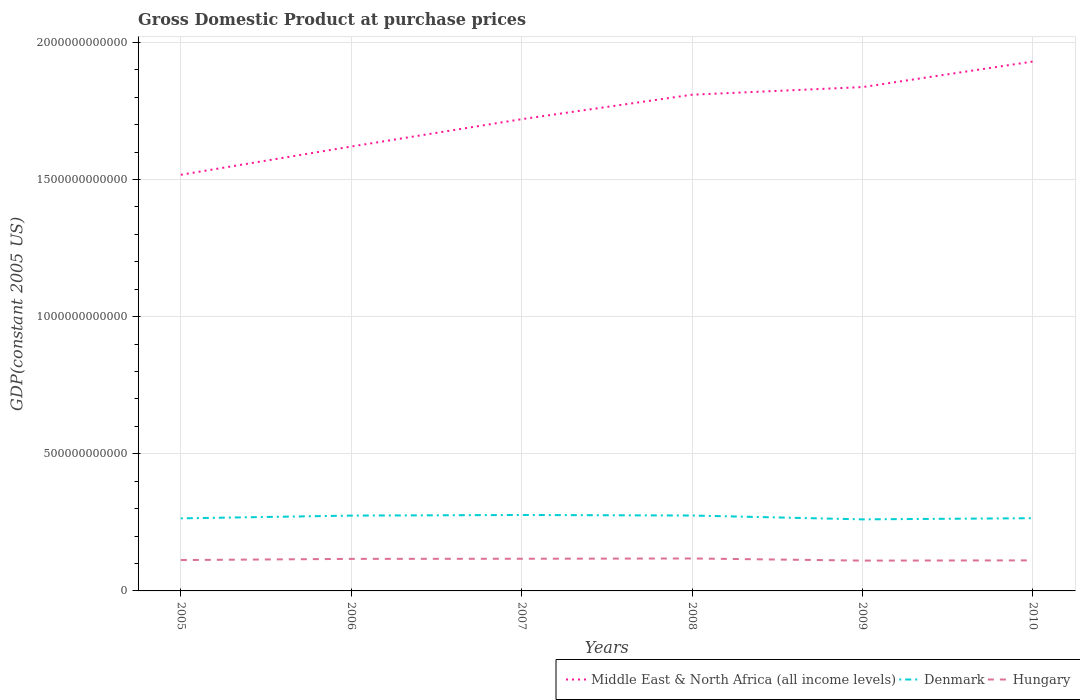How many different coloured lines are there?
Your response must be concise. 3. Across all years, what is the maximum GDP at purchase prices in Middle East & North Africa (all income levels)?
Keep it short and to the point. 1.52e+12. In which year was the GDP at purchase prices in Denmark maximum?
Give a very brief answer. 2009. What is the total GDP at purchase prices in Hungary in the graph?
Your answer should be compact. -4.78e+09. What is the difference between the highest and the second highest GDP at purchase prices in Middle East & North Africa (all income levels)?
Provide a short and direct response. 4.13e+11. Is the GDP at purchase prices in Denmark strictly greater than the GDP at purchase prices in Hungary over the years?
Offer a terse response. No. How many years are there in the graph?
Provide a succinct answer. 6. What is the difference between two consecutive major ticks on the Y-axis?
Your answer should be very brief. 5.00e+11. Are the values on the major ticks of Y-axis written in scientific E-notation?
Offer a terse response. No. How are the legend labels stacked?
Your answer should be compact. Horizontal. What is the title of the graph?
Offer a terse response. Gross Domestic Product at purchase prices. What is the label or title of the Y-axis?
Your answer should be compact. GDP(constant 2005 US). What is the GDP(constant 2005 US) of Middle East & North Africa (all income levels) in 2005?
Your response must be concise. 1.52e+12. What is the GDP(constant 2005 US) in Denmark in 2005?
Your response must be concise. 2.65e+11. What is the GDP(constant 2005 US) in Hungary in 2005?
Your answer should be compact. 1.13e+11. What is the GDP(constant 2005 US) in Middle East & North Africa (all income levels) in 2006?
Offer a terse response. 1.62e+12. What is the GDP(constant 2005 US) of Denmark in 2006?
Your answer should be compact. 2.75e+11. What is the GDP(constant 2005 US) of Hungary in 2006?
Your answer should be very brief. 1.17e+11. What is the GDP(constant 2005 US) in Middle East & North Africa (all income levels) in 2007?
Provide a short and direct response. 1.72e+12. What is the GDP(constant 2005 US) in Denmark in 2007?
Keep it short and to the point. 2.77e+11. What is the GDP(constant 2005 US) of Hungary in 2007?
Give a very brief answer. 1.17e+11. What is the GDP(constant 2005 US) of Middle East & North Africa (all income levels) in 2008?
Your answer should be very brief. 1.81e+12. What is the GDP(constant 2005 US) of Denmark in 2008?
Offer a terse response. 2.75e+11. What is the GDP(constant 2005 US) of Hungary in 2008?
Keep it short and to the point. 1.18e+11. What is the GDP(constant 2005 US) in Middle East & North Africa (all income levels) in 2009?
Give a very brief answer. 1.84e+12. What is the GDP(constant 2005 US) in Denmark in 2009?
Offer a very short reply. 2.61e+11. What is the GDP(constant 2005 US) of Hungary in 2009?
Make the answer very short. 1.11e+11. What is the GDP(constant 2005 US) of Middle East & North Africa (all income levels) in 2010?
Provide a short and direct response. 1.93e+12. What is the GDP(constant 2005 US) of Denmark in 2010?
Your answer should be very brief. 2.65e+11. What is the GDP(constant 2005 US) of Hungary in 2010?
Your answer should be compact. 1.11e+11. Across all years, what is the maximum GDP(constant 2005 US) in Middle East & North Africa (all income levels)?
Make the answer very short. 1.93e+12. Across all years, what is the maximum GDP(constant 2005 US) of Denmark?
Your response must be concise. 2.77e+11. Across all years, what is the maximum GDP(constant 2005 US) in Hungary?
Provide a succinct answer. 1.18e+11. Across all years, what is the minimum GDP(constant 2005 US) of Middle East & North Africa (all income levels)?
Provide a short and direct response. 1.52e+12. Across all years, what is the minimum GDP(constant 2005 US) in Denmark?
Provide a succinct answer. 2.61e+11. Across all years, what is the minimum GDP(constant 2005 US) in Hungary?
Your answer should be very brief. 1.11e+11. What is the total GDP(constant 2005 US) in Middle East & North Africa (all income levels) in the graph?
Make the answer very short. 1.04e+13. What is the total GDP(constant 2005 US) of Denmark in the graph?
Offer a very short reply. 1.62e+12. What is the total GDP(constant 2005 US) in Hungary in the graph?
Your response must be concise. 6.87e+11. What is the difference between the GDP(constant 2005 US) in Middle East & North Africa (all income levels) in 2005 and that in 2006?
Offer a terse response. -1.03e+11. What is the difference between the GDP(constant 2005 US) of Denmark in 2005 and that in 2006?
Make the answer very short. -1.00e+1. What is the difference between the GDP(constant 2005 US) of Hungary in 2005 and that in 2006?
Give a very brief answer. -4.28e+09. What is the difference between the GDP(constant 2005 US) of Middle East & North Africa (all income levels) in 2005 and that in 2007?
Offer a terse response. -2.03e+11. What is the difference between the GDP(constant 2005 US) of Denmark in 2005 and that in 2007?
Offer a very short reply. -1.23e+1. What is the difference between the GDP(constant 2005 US) in Hungary in 2005 and that in 2007?
Your answer should be very brief. -4.78e+09. What is the difference between the GDP(constant 2005 US) of Middle East & North Africa (all income levels) in 2005 and that in 2008?
Provide a short and direct response. -2.92e+11. What is the difference between the GDP(constant 2005 US) in Denmark in 2005 and that in 2008?
Offer a very short reply. -1.03e+1. What is the difference between the GDP(constant 2005 US) of Hungary in 2005 and that in 2008?
Provide a succinct answer. -5.77e+09. What is the difference between the GDP(constant 2005 US) in Middle East & North Africa (all income levels) in 2005 and that in 2009?
Your answer should be very brief. -3.20e+11. What is the difference between the GDP(constant 2005 US) of Denmark in 2005 and that in 2009?
Make the answer very short. 3.66e+09. What is the difference between the GDP(constant 2005 US) of Hungary in 2005 and that in 2009?
Your answer should be very brief. 1.99e+09. What is the difference between the GDP(constant 2005 US) in Middle East & North Africa (all income levels) in 2005 and that in 2010?
Provide a short and direct response. -4.13e+11. What is the difference between the GDP(constant 2005 US) of Denmark in 2005 and that in 2010?
Your answer should be very brief. -5.75e+08. What is the difference between the GDP(constant 2005 US) of Hungary in 2005 and that in 2010?
Offer a very short reply. 1.17e+09. What is the difference between the GDP(constant 2005 US) of Middle East & North Africa (all income levels) in 2006 and that in 2007?
Offer a terse response. -9.97e+1. What is the difference between the GDP(constant 2005 US) in Denmark in 2006 and that in 2007?
Offer a very short reply. -2.26e+09. What is the difference between the GDP(constant 2005 US) of Hungary in 2006 and that in 2007?
Make the answer very short. -4.97e+08. What is the difference between the GDP(constant 2005 US) in Middle East & North Africa (all income levels) in 2006 and that in 2008?
Keep it short and to the point. -1.89e+11. What is the difference between the GDP(constant 2005 US) in Denmark in 2006 and that in 2008?
Your response must be concise. -2.76e+08. What is the difference between the GDP(constant 2005 US) of Hungary in 2006 and that in 2008?
Your answer should be compact. -1.48e+09. What is the difference between the GDP(constant 2005 US) in Middle East & North Africa (all income levels) in 2006 and that in 2009?
Keep it short and to the point. -2.17e+11. What is the difference between the GDP(constant 2005 US) of Denmark in 2006 and that in 2009?
Offer a terse response. 1.37e+1. What is the difference between the GDP(constant 2005 US) of Hungary in 2006 and that in 2009?
Give a very brief answer. 6.28e+09. What is the difference between the GDP(constant 2005 US) of Middle East & North Africa (all income levels) in 2006 and that in 2010?
Offer a terse response. -3.10e+11. What is the difference between the GDP(constant 2005 US) of Denmark in 2006 and that in 2010?
Provide a short and direct response. 9.47e+09. What is the difference between the GDP(constant 2005 US) in Hungary in 2006 and that in 2010?
Your answer should be compact. 5.46e+09. What is the difference between the GDP(constant 2005 US) of Middle East & North Africa (all income levels) in 2007 and that in 2008?
Make the answer very short. -8.92e+1. What is the difference between the GDP(constant 2005 US) in Denmark in 2007 and that in 2008?
Your answer should be very brief. 1.99e+09. What is the difference between the GDP(constant 2005 US) of Hungary in 2007 and that in 2008?
Your answer should be very brief. -9.85e+08. What is the difference between the GDP(constant 2005 US) of Middle East & North Africa (all income levels) in 2007 and that in 2009?
Provide a succinct answer. -1.17e+11. What is the difference between the GDP(constant 2005 US) of Denmark in 2007 and that in 2009?
Give a very brief answer. 1.60e+1. What is the difference between the GDP(constant 2005 US) in Hungary in 2007 and that in 2009?
Offer a very short reply. 6.77e+09. What is the difference between the GDP(constant 2005 US) of Middle East & North Africa (all income levels) in 2007 and that in 2010?
Ensure brevity in your answer.  -2.10e+11. What is the difference between the GDP(constant 2005 US) of Denmark in 2007 and that in 2010?
Offer a very short reply. 1.17e+1. What is the difference between the GDP(constant 2005 US) of Hungary in 2007 and that in 2010?
Your response must be concise. 5.95e+09. What is the difference between the GDP(constant 2005 US) in Middle East & North Africa (all income levels) in 2008 and that in 2009?
Ensure brevity in your answer.  -2.78e+1. What is the difference between the GDP(constant 2005 US) in Denmark in 2008 and that in 2009?
Keep it short and to the point. 1.40e+1. What is the difference between the GDP(constant 2005 US) of Hungary in 2008 and that in 2009?
Give a very brief answer. 7.76e+09. What is the difference between the GDP(constant 2005 US) of Middle East & North Africa (all income levels) in 2008 and that in 2010?
Provide a succinct answer. -1.21e+11. What is the difference between the GDP(constant 2005 US) in Denmark in 2008 and that in 2010?
Offer a very short reply. 9.75e+09. What is the difference between the GDP(constant 2005 US) in Hungary in 2008 and that in 2010?
Provide a short and direct response. 6.94e+09. What is the difference between the GDP(constant 2005 US) of Middle East & North Africa (all income levels) in 2009 and that in 2010?
Make the answer very short. -9.32e+1. What is the difference between the GDP(constant 2005 US) in Denmark in 2009 and that in 2010?
Provide a short and direct response. -4.24e+09. What is the difference between the GDP(constant 2005 US) of Hungary in 2009 and that in 2010?
Provide a short and direct response. -8.22e+08. What is the difference between the GDP(constant 2005 US) in Middle East & North Africa (all income levels) in 2005 and the GDP(constant 2005 US) in Denmark in 2006?
Your answer should be compact. 1.24e+12. What is the difference between the GDP(constant 2005 US) in Middle East & North Africa (all income levels) in 2005 and the GDP(constant 2005 US) in Hungary in 2006?
Provide a succinct answer. 1.40e+12. What is the difference between the GDP(constant 2005 US) of Denmark in 2005 and the GDP(constant 2005 US) of Hungary in 2006?
Offer a terse response. 1.48e+11. What is the difference between the GDP(constant 2005 US) of Middle East & North Africa (all income levels) in 2005 and the GDP(constant 2005 US) of Denmark in 2007?
Keep it short and to the point. 1.24e+12. What is the difference between the GDP(constant 2005 US) in Middle East & North Africa (all income levels) in 2005 and the GDP(constant 2005 US) in Hungary in 2007?
Give a very brief answer. 1.40e+12. What is the difference between the GDP(constant 2005 US) of Denmark in 2005 and the GDP(constant 2005 US) of Hungary in 2007?
Provide a short and direct response. 1.47e+11. What is the difference between the GDP(constant 2005 US) in Middle East & North Africa (all income levels) in 2005 and the GDP(constant 2005 US) in Denmark in 2008?
Provide a succinct answer. 1.24e+12. What is the difference between the GDP(constant 2005 US) of Middle East & North Africa (all income levels) in 2005 and the GDP(constant 2005 US) of Hungary in 2008?
Provide a succinct answer. 1.40e+12. What is the difference between the GDP(constant 2005 US) of Denmark in 2005 and the GDP(constant 2005 US) of Hungary in 2008?
Your response must be concise. 1.46e+11. What is the difference between the GDP(constant 2005 US) of Middle East & North Africa (all income levels) in 2005 and the GDP(constant 2005 US) of Denmark in 2009?
Ensure brevity in your answer.  1.26e+12. What is the difference between the GDP(constant 2005 US) in Middle East & North Africa (all income levels) in 2005 and the GDP(constant 2005 US) in Hungary in 2009?
Give a very brief answer. 1.41e+12. What is the difference between the GDP(constant 2005 US) of Denmark in 2005 and the GDP(constant 2005 US) of Hungary in 2009?
Ensure brevity in your answer.  1.54e+11. What is the difference between the GDP(constant 2005 US) of Middle East & North Africa (all income levels) in 2005 and the GDP(constant 2005 US) of Denmark in 2010?
Provide a short and direct response. 1.25e+12. What is the difference between the GDP(constant 2005 US) of Middle East & North Africa (all income levels) in 2005 and the GDP(constant 2005 US) of Hungary in 2010?
Give a very brief answer. 1.41e+12. What is the difference between the GDP(constant 2005 US) of Denmark in 2005 and the GDP(constant 2005 US) of Hungary in 2010?
Your answer should be compact. 1.53e+11. What is the difference between the GDP(constant 2005 US) in Middle East & North Africa (all income levels) in 2006 and the GDP(constant 2005 US) in Denmark in 2007?
Provide a succinct answer. 1.34e+12. What is the difference between the GDP(constant 2005 US) in Middle East & North Africa (all income levels) in 2006 and the GDP(constant 2005 US) in Hungary in 2007?
Give a very brief answer. 1.50e+12. What is the difference between the GDP(constant 2005 US) in Denmark in 2006 and the GDP(constant 2005 US) in Hungary in 2007?
Offer a terse response. 1.57e+11. What is the difference between the GDP(constant 2005 US) in Middle East & North Africa (all income levels) in 2006 and the GDP(constant 2005 US) in Denmark in 2008?
Your response must be concise. 1.35e+12. What is the difference between the GDP(constant 2005 US) of Middle East & North Africa (all income levels) in 2006 and the GDP(constant 2005 US) of Hungary in 2008?
Offer a terse response. 1.50e+12. What is the difference between the GDP(constant 2005 US) of Denmark in 2006 and the GDP(constant 2005 US) of Hungary in 2008?
Offer a terse response. 1.56e+11. What is the difference between the GDP(constant 2005 US) of Middle East & North Africa (all income levels) in 2006 and the GDP(constant 2005 US) of Denmark in 2009?
Your response must be concise. 1.36e+12. What is the difference between the GDP(constant 2005 US) in Middle East & North Africa (all income levels) in 2006 and the GDP(constant 2005 US) in Hungary in 2009?
Make the answer very short. 1.51e+12. What is the difference between the GDP(constant 2005 US) in Denmark in 2006 and the GDP(constant 2005 US) in Hungary in 2009?
Give a very brief answer. 1.64e+11. What is the difference between the GDP(constant 2005 US) of Middle East & North Africa (all income levels) in 2006 and the GDP(constant 2005 US) of Denmark in 2010?
Your answer should be very brief. 1.35e+12. What is the difference between the GDP(constant 2005 US) in Middle East & North Africa (all income levels) in 2006 and the GDP(constant 2005 US) in Hungary in 2010?
Provide a short and direct response. 1.51e+12. What is the difference between the GDP(constant 2005 US) of Denmark in 2006 and the GDP(constant 2005 US) of Hungary in 2010?
Keep it short and to the point. 1.63e+11. What is the difference between the GDP(constant 2005 US) of Middle East & North Africa (all income levels) in 2007 and the GDP(constant 2005 US) of Denmark in 2008?
Offer a terse response. 1.44e+12. What is the difference between the GDP(constant 2005 US) of Middle East & North Africa (all income levels) in 2007 and the GDP(constant 2005 US) of Hungary in 2008?
Provide a succinct answer. 1.60e+12. What is the difference between the GDP(constant 2005 US) of Denmark in 2007 and the GDP(constant 2005 US) of Hungary in 2008?
Your answer should be compact. 1.59e+11. What is the difference between the GDP(constant 2005 US) of Middle East & North Africa (all income levels) in 2007 and the GDP(constant 2005 US) of Denmark in 2009?
Offer a very short reply. 1.46e+12. What is the difference between the GDP(constant 2005 US) in Middle East & North Africa (all income levels) in 2007 and the GDP(constant 2005 US) in Hungary in 2009?
Make the answer very short. 1.61e+12. What is the difference between the GDP(constant 2005 US) in Denmark in 2007 and the GDP(constant 2005 US) in Hungary in 2009?
Ensure brevity in your answer.  1.66e+11. What is the difference between the GDP(constant 2005 US) of Middle East & North Africa (all income levels) in 2007 and the GDP(constant 2005 US) of Denmark in 2010?
Keep it short and to the point. 1.45e+12. What is the difference between the GDP(constant 2005 US) of Middle East & North Africa (all income levels) in 2007 and the GDP(constant 2005 US) of Hungary in 2010?
Provide a short and direct response. 1.61e+12. What is the difference between the GDP(constant 2005 US) of Denmark in 2007 and the GDP(constant 2005 US) of Hungary in 2010?
Make the answer very short. 1.66e+11. What is the difference between the GDP(constant 2005 US) of Middle East & North Africa (all income levels) in 2008 and the GDP(constant 2005 US) of Denmark in 2009?
Your response must be concise. 1.55e+12. What is the difference between the GDP(constant 2005 US) in Middle East & North Africa (all income levels) in 2008 and the GDP(constant 2005 US) in Hungary in 2009?
Provide a succinct answer. 1.70e+12. What is the difference between the GDP(constant 2005 US) of Denmark in 2008 and the GDP(constant 2005 US) of Hungary in 2009?
Your answer should be very brief. 1.64e+11. What is the difference between the GDP(constant 2005 US) in Middle East & North Africa (all income levels) in 2008 and the GDP(constant 2005 US) in Denmark in 2010?
Offer a terse response. 1.54e+12. What is the difference between the GDP(constant 2005 US) in Middle East & North Africa (all income levels) in 2008 and the GDP(constant 2005 US) in Hungary in 2010?
Your response must be concise. 1.70e+12. What is the difference between the GDP(constant 2005 US) of Denmark in 2008 and the GDP(constant 2005 US) of Hungary in 2010?
Offer a very short reply. 1.64e+11. What is the difference between the GDP(constant 2005 US) in Middle East & North Africa (all income levels) in 2009 and the GDP(constant 2005 US) in Denmark in 2010?
Provide a succinct answer. 1.57e+12. What is the difference between the GDP(constant 2005 US) of Middle East & North Africa (all income levels) in 2009 and the GDP(constant 2005 US) of Hungary in 2010?
Give a very brief answer. 1.73e+12. What is the difference between the GDP(constant 2005 US) of Denmark in 2009 and the GDP(constant 2005 US) of Hungary in 2010?
Make the answer very short. 1.50e+11. What is the average GDP(constant 2005 US) of Middle East & North Africa (all income levels) per year?
Your response must be concise. 1.74e+12. What is the average GDP(constant 2005 US) of Denmark per year?
Give a very brief answer. 2.69e+11. What is the average GDP(constant 2005 US) of Hungary per year?
Provide a short and direct response. 1.14e+11. In the year 2005, what is the difference between the GDP(constant 2005 US) in Middle East & North Africa (all income levels) and GDP(constant 2005 US) in Denmark?
Provide a succinct answer. 1.25e+12. In the year 2005, what is the difference between the GDP(constant 2005 US) of Middle East & North Africa (all income levels) and GDP(constant 2005 US) of Hungary?
Make the answer very short. 1.40e+12. In the year 2005, what is the difference between the GDP(constant 2005 US) of Denmark and GDP(constant 2005 US) of Hungary?
Make the answer very short. 1.52e+11. In the year 2006, what is the difference between the GDP(constant 2005 US) in Middle East & North Africa (all income levels) and GDP(constant 2005 US) in Denmark?
Make the answer very short. 1.35e+12. In the year 2006, what is the difference between the GDP(constant 2005 US) of Middle East & North Africa (all income levels) and GDP(constant 2005 US) of Hungary?
Ensure brevity in your answer.  1.50e+12. In the year 2006, what is the difference between the GDP(constant 2005 US) in Denmark and GDP(constant 2005 US) in Hungary?
Provide a succinct answer. 1.58e+11. In the year 2007, what is the difference between the GDP(constant 2005 US) in Middle East & North Africa (all income levels) and GDP(constant 2005 US) in Denmark?
Give a very brief answer. 1.44e+12. In the year 2007, what is the difference between the GDP(constant 2005 US) of Middle East & North Africa (all income levels) and GDP(constant 2005 US) of Hungary?
Provide a short and direct response. 1.60e+12. In the year 2007, what is the difference between the GDP(constant 2005 US) of Denmark and GDP(constant 2005 US) of Hungary?
Provide a succinct answer. 1.60e+11. In the year 2008, what is the difference between the GDP(constant 2005 US) in Middle East & North Africa (all income levels) and GDP(constant 2005 US) in Denmark?
Ensure brevity in your answer.  1.53e+12. In the year 2008, what is the difference between the GDP(constant 2005 US) in Middle East & North Africa (all income levels) and GDP(constant 2005 US) in Hungary?
Ensure brevity in your answer.  1.69e+12. In the year 2008, what is the difference between the GDP(constant 2005 US) in Denmark and GDP(constant 2005 US) in Hungary?
Keep it short and to the point. 1.57e+11. In the year 2009, what is the difference between the GDP(constant 2005 US) of Middle East & North Africa (all income levels) and GDP(constant 2005 US) of Denmark?
Your answer should be compact. 1.58e+12. In the year 2009, what is the difference between the GDP(constant 2005 US) of Middle East & North Africa (all income levels) and GDP(constant 2005 US) of Hungary?
Offer a terse response. 1.73e+12. In the year 2009, what is the difference between the GDP(constant 2005 US) of Denmark and GDP(constant 2005 US) of Hungary?
Provide a succinct answer. 1.50e+11. In the year 2010, what is the difference between the GDP(constant 2005 US) in Middle East & North Africa (all income levels) and GDP(constant 2005 US) in Denmark?
Make the answer very short. 1.66e+12. In the year 2010, what is the difference between the GDP(constant 2005 US) in Middle East & North Africa (all income levels) and GDP(constant 2005 US) in Hungary?
Ensure brevity in your answer.  1.82e+12. In the year 2010, what is the difference between the GDP(constant 2005 US) of Denmark and GDP(constant 2005 US) of Hungary?
Offer a very short reply. 1.54e+11. What is the ratio of the GDP(constant 2005 US) in Middle East & North Africa (all income levels) in 2005 to that in 2006?
Your answer should be compact. 0.94. What is the ratio of the GDP(constant 2005 US) of Denmark in 2005 to that in 2006?
Your response must be concise. 0.96. What is the ratio of the GDP(constant 2005 US) in Hungary in 2005 to that in 2006?
Keep it short and to the point. 0.96. What is the ratio of the GDP(constant 2005 US) of Middle East & North Africa (all income levels) in 2005 to that in 2007?
Your answer should be very brief. 0.88. What is the ratio of the GDP(constant 2005 US) in Denmark in 2005 to that in 2007?
Provide a short and direct response. 0.96. What is the ratio of the GDP(constant 2005 US) in Hungary in 2005 to that in 2007?
Make the answer very short. 0.96. What is the ratio of the GDP(constant 2005 US) in Middle East & North Africa (all income levels) in 2005 to that in 2008?
Make the answer very short. 0.84. What is the ratio of the GDP(constant 2005 US) in Denmark in 2005 to that in 2008?
Your answer should be very brief. 0.96. What is the ratio of the GDP(constant 2005 US) in Hungary in 2005 to that in 2008?
Your answer should be very brief. 0.95. What is the ratio of the GDP(constant 2005 US) in Middle East & North Africa (all income levels) in 2005 to that in 2009?
Ensure brevity in your answer.  0.83. What is the ratio of the GDP(constant 2005 US) of Hungary in 2005 to that in 2009?
Offer a terse response. 1.02. What is the ratio of the GDP(constant 2005 US) of Middle East & North Africa (all income levels) in 2005 to that in 2010?
Keep it short and to the point. 0.79. What is the ratio of the GDP(constant 2005 US) in Hungary in 2005 to that in 2010?
Your response must be concise. 1.01. What is the ratio of the GDP(constant 2005 US) of Middle East & North Africa (all income levels) in 2006 to that in 2007?
Offer a very short reply. 0.94. What is the ratio of the GDP(constant 2005 US) of Denmark in 2006 to that in 2007?
Give a very brief answer. 0.99. What is the ratio of the GDP(constant 2005 US) of Middle East & North Africa (all income levels) in 2006 to that in 2008?
Your response must be concise. 0.9. What is the ratio of the GDP(constant 2005 US) in Denmark in 2006 to that in 2008?
Give a very brief answer. 1. What is the ratio of the GDP(constant 2005 US) in Hungary in 2006 to that in 2008?
Provide a short and direct response. 0.99. What is the ratio of the GDP(constant 2005 US) in Middle East & North Africa (all income levels) in 2006 to that in 2009?
Your answer should be very brief. 0.88. What is the ratio of the GDP(constant 2005 US) of Denmark in 2006 to that in 2009?
Offer a terse response. 1.05. What is the ratio of the GDP(constant 2005 US) in Hungary in 2006 to that in 2009?
Offer a terse response. 1.06. What is the ratio of the GDP(constant 2005 US) in Middle East & North Africa (all income levels) in 2006 to that in 2010?
Provide a succinct answer. 0.84. What is the ratio of the GDP(constant 2005 US) of Denmark in 2006 to that in 2010?
Give a very brief answer. 1.04. What is the ratio of the GDP(constant 2005 US) of Hungary in 2006 to that in 2010?
Provide a succinct answer. 1.05. What is the ratio of the GDP(constant 2005 US) in Middle East & North Africa (all income levels) in 2007 to that in 2008?
Your answer should be compact. 0.95. What is the ratio of the GDP(constant 2005 US) in Middle East & North Africa (all income levels) in 2007 to that in 2009?
Ensure brevity in your answer.  0.94. What is the ratio of the GDP(constant 2005 US) in Denmark in 2007 to that in 2009?
Your answer should be compact. 1.06. What is the ratio of the GDP(constant 2005 US) of Hungary in 2007 to that in 2009?
Offer a very short reply. 1.06. What is the ratio of the GDP(constant 2005 US) in Middle East & North Africa (all income levels) in 2007 to that in 2010?
Keep it short and to the point. 0.89. What is the ratio of the GDP(constant 2005 US) in Denmark in 2007 to that in 2010?
Give a very brief answer. 1.04. What is the ratio of the GDP(constant 2005 US) in Hungary in 2007 to that in 2010?
Keep it short and to the point. 1.05. What is the ratio of the GDP(constant 2005 US) in Middle East & North Africa (all income levels) in 2008 to that in 2009?
Offer a very short reply. 0.98. What is the ratio of the GDP(constant 2005 US) in Denmark in 2008 to that in 2009?
Offer a terse response. 1.05. What is the ratio of the GDP(constant 2005 US) in Hungary in 2008 to that in 2009?
Keep it short and to the point. 1.07. What is the ratio of the GDP(constant 2005 US) of Middle East & North Africa (all income levels) in 2008 to that in 2010?
Make the answer very short. 0.94. What is the ratio of the GDP(constant 2005 US) of Denmark in 2008 to that in 2010?
Ensure brevity in your answer.  1.04. What is the ratio of the GDP(constant 2005 US) of Hungary in 2008 to that in 2010?
Make the answer very short. 1.06. What is the ratio of the GDP(constant 2005 US) of Middle East & North Africa (all income levels) in 2009 to that in 2010?
Ensure brevity in your answer.  0.95. What is the ratio of the GDP(constant 2005 US) of Denmark in 2009 to that in 2010?
Ensure brevity in your answer.  0.98. What is the ratio of the GDP(constant 2005 US) in Hungary in 2009 to that in 2010?
Provide a short and direct response. 0.99. What is the difference between the highest and the second highest GDP(constant 2005 US) of Middle East & North Africa (all income levels)?
Your answer should be very brief. 9.32e+1. What is the difference between the highest and the second highest GDP(constant 2005 US) of Denmark?
Give a very brief answer. 1.99e+09. What is the difference between the highest and the second highest GDP(constant 2005 US) of Hungary?
Ensure brevity in your answer.  9.85e+08. What is the difference between the highest and the lowest GDP(constant 2005 US) of Middle East & North Africa (all income levels)?
Your answer should be very brief. 4.13e+11. What is the difference between the highest and the lowest GDP(constant 2005 US) in Denmark?
Your response must be concise. 1.60e+1. What is the difference between the highest and the lowest GDP(constant 2005 US) in Hungary?
Provide a succinct answer. 7.76e+09. 